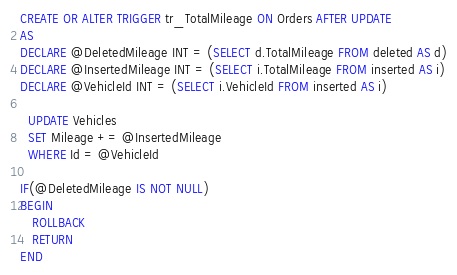<code> <loc_0><loc_0><loc_500><loc_500><_SQL_>CREATE OR ALTER TRIGGER tr_TotalMileage ON Orders AFTER UPDATE
AS
DECLARE @DeletedMileage INT = (SELECT d.TotalMileage FROM deleted AS d)
DECLARE @InsertedMileage INT = (SELECT i.TotalMileage FROM inserted AS i)
DECLARE @VehicleId INT = (SELECT i.VehicleId FROM inserted AS i)
  
  UPDATE Vehicles
  SET Mileage += @InsertedMileage
  WHERE Id = @VehicleId

IF(@DeletedMileage IS NOT NULL)
BEGIN
   ROLLBACK
   RETURN
END</code> 